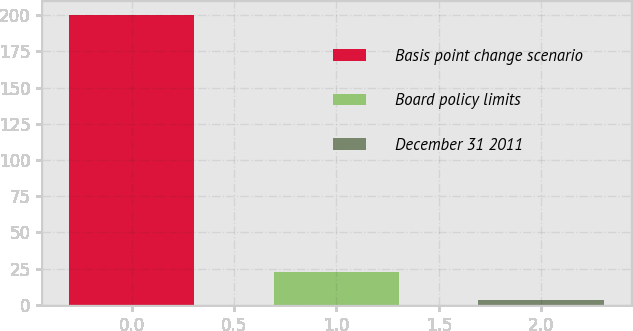Convert chart. <chart><loc_0><loc_0><loc_500><loc_500><bar_chart><fcel>Basis point change scenario<fcel>Board policy limits<fcel>December 31 2011<nl><fcel>200<fcel>23.06<fcel>3.4<nl></chart> 